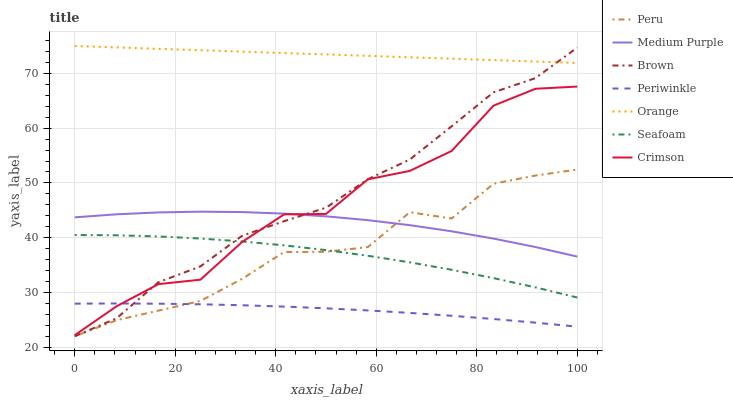Does Periwinkle have the minimum area under the curve?
Answer yes or no. Yes. Does Orange have the maximum area under the curve?
Answer yes or no. Yes. Does Seafoam have the minimum area under the curve?
Answer yes or no. No. Does Seafoam have the maximum area under the curve?
Answer yes or no. No. Is Orange the smoothest?
Answer yes or no. Yes. Is Crimson the roughest?
Answer yes or no. Yes. Is Seafoam the smoothest?
Answer yes or no. No. Is Seafoam the roughest?
Answer yes or no. No. Does Brown have the lowest value?
Answer yes or no. Yes. Does Seafoam have the lowest value?
Answer yes or no. No. Does Orange have the highest value?
Answer yes or no. Yes. Does Seafoam have the highest value?
Answer yes or no. No. Is Periwinkle less than Orange?
Answer yes or no. Yes. Is Medium Purple greater than Periwinkle?
Answer yes or no. Yes. Does Periwinkle intersect Crimson?
Answer yes or no. Yes. Is Periwinkle less than Crimson?
Answer yes or no. No. Is Periwinkle greater than Crimson?
Answer yes or no. No. Does Periwinkle intersect Orange?
Answer yes or no. No. 